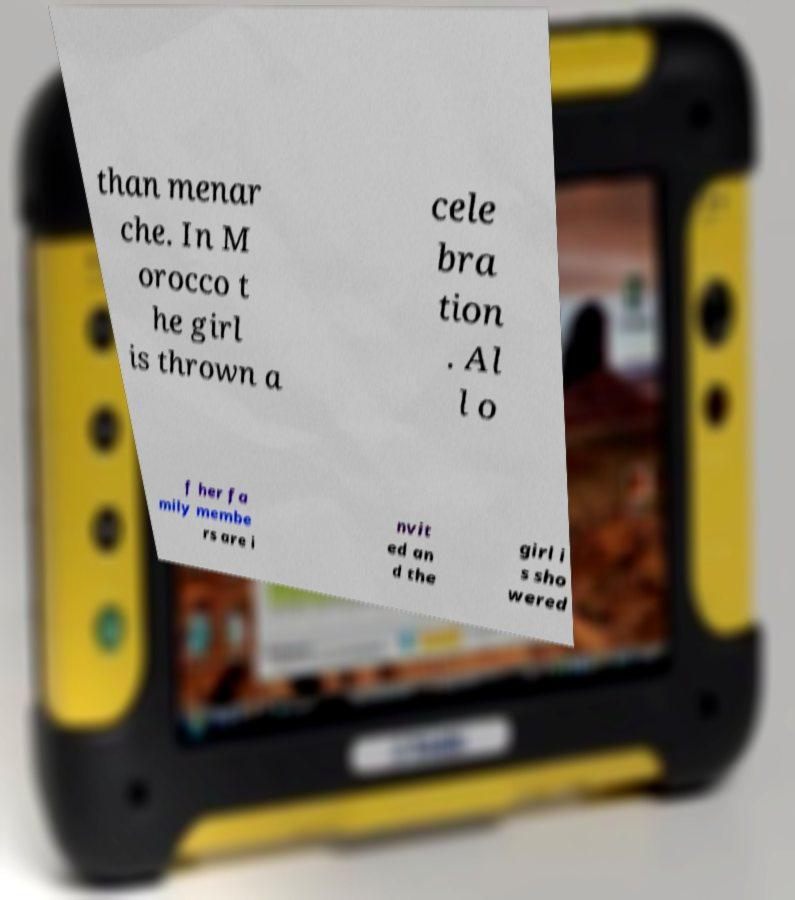Can you read and provide the text displayed in the image?This photo seems to have some interesting text. Can you extract and type it out for me? than menar che. In M orocco t he girl is thrown a cele bra tion . Al l o f her fa mily membe rs are i nvit ed an d the girl i s sho wered 